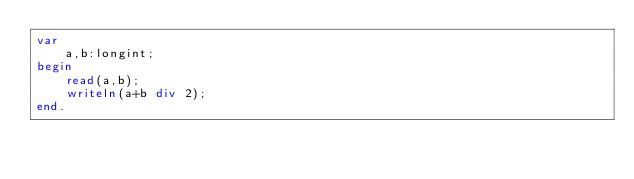Convert code to text. <code><loc_0><loc_0><loc_500><loc_500><_Pascal_>var
    a,b:longint;
begin
    read(a,b);
    writeln(a+b div 2);
end.</code> 